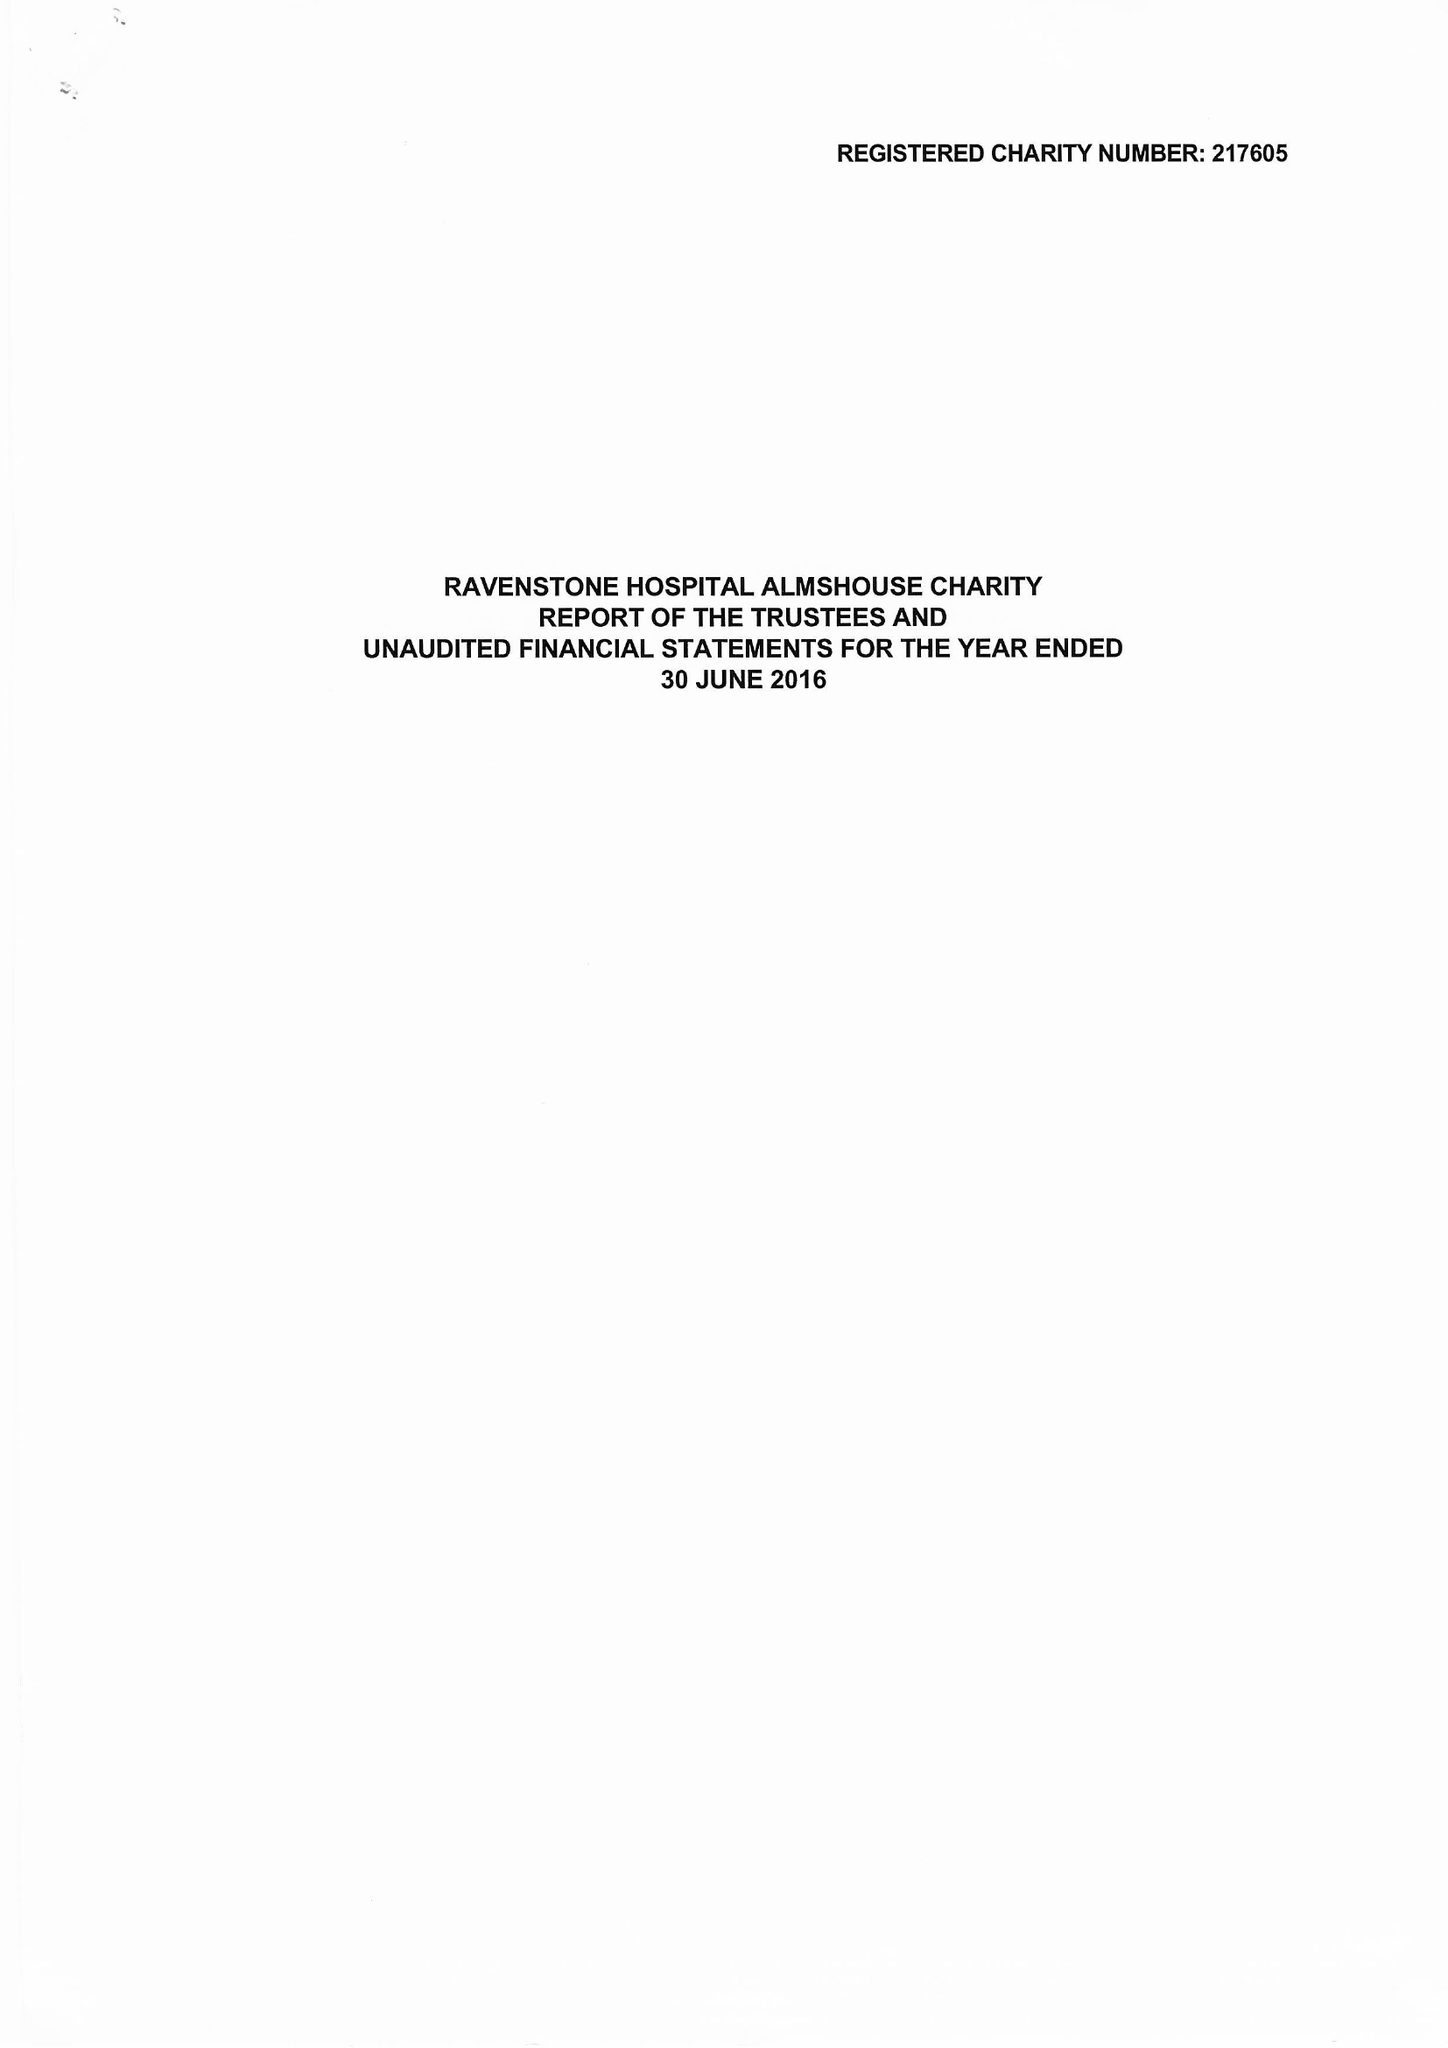What is the value for the address__street_line?
Answer the question using a single word or phrase. HIGH STREET 